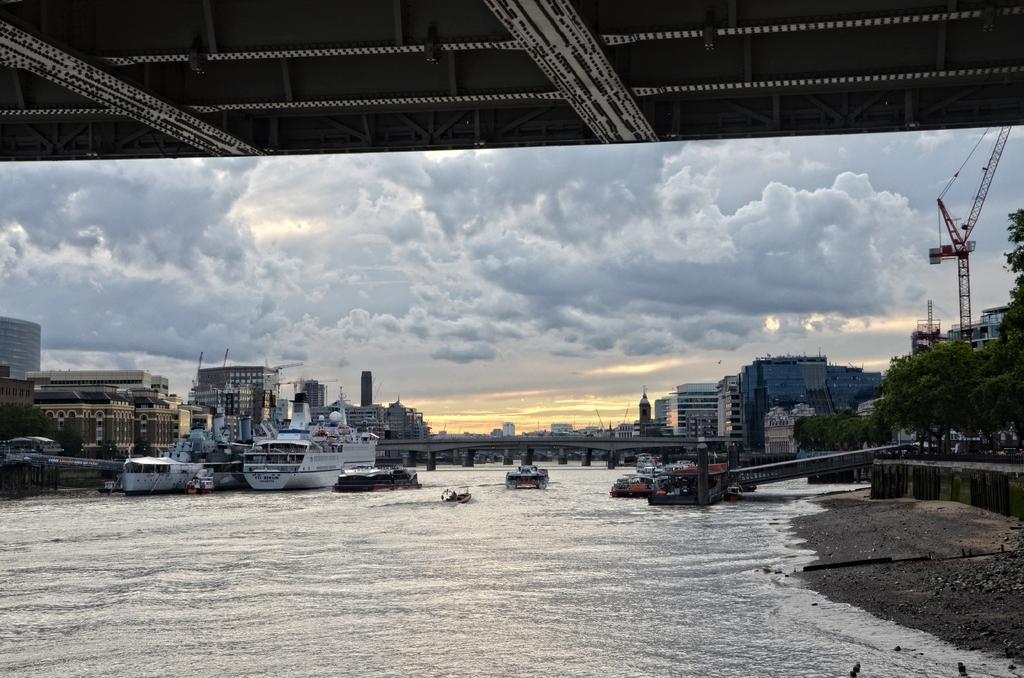Describe this image in one or two sentences. In this picture we can see boats and ships on the water. In the background there is a breach and many buildings. On the left we can see crane and trees. In the background we can see sky and clouds. 